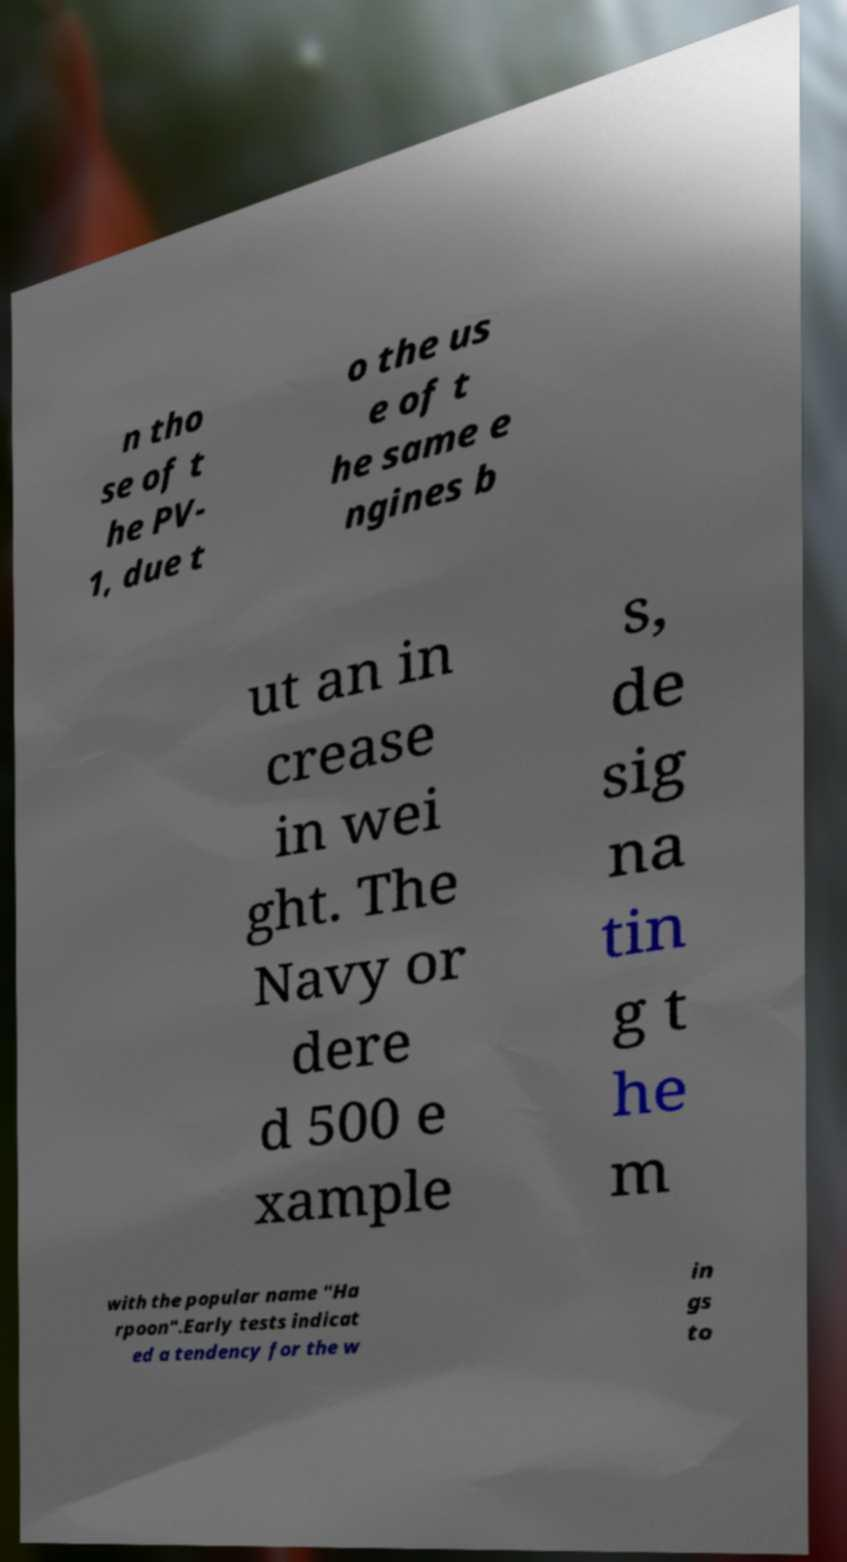Please identify and transcribe the text found in this image. n tho se of t he PV- 1, due t o the us e of t he same e ngines b ut an in crease in wei ght. The Navy or dere d 500 e xample s, de sig na tin g t he m with the popular name "Ha rpoon".Early tests indicat ed a tendency for the w in gs to 